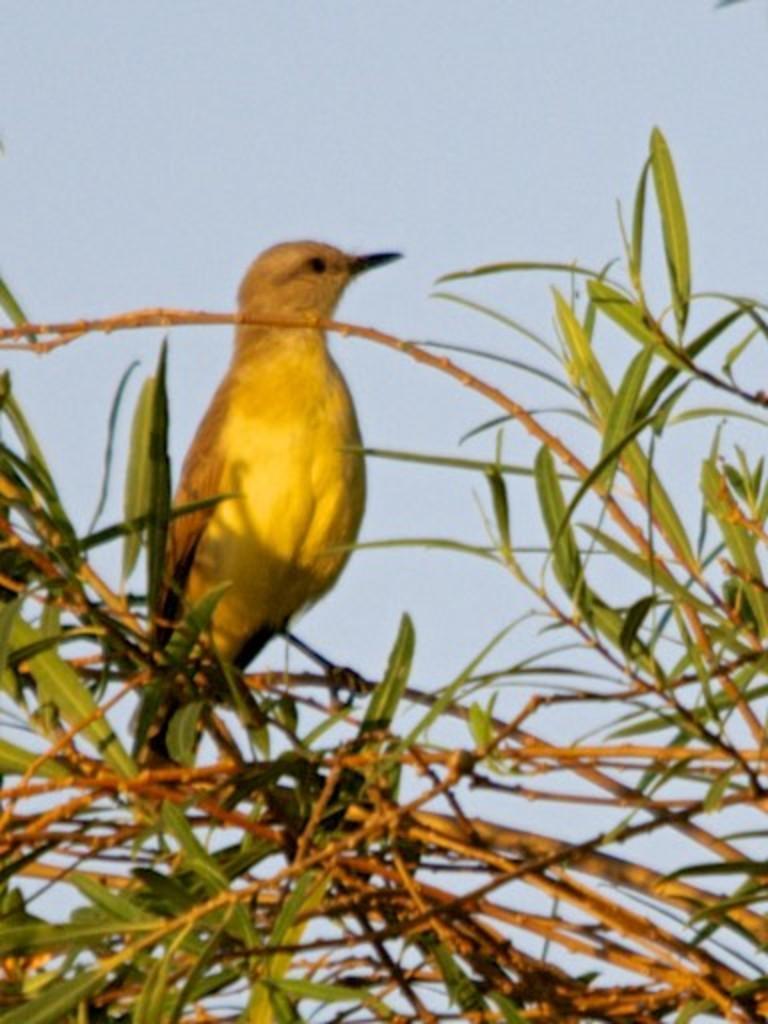Describe this image in one or two sentences. In this image there is a tree truncated towards the bottom of the image, there is a bird on the tree, at the background of the image there is the sky truncated. 